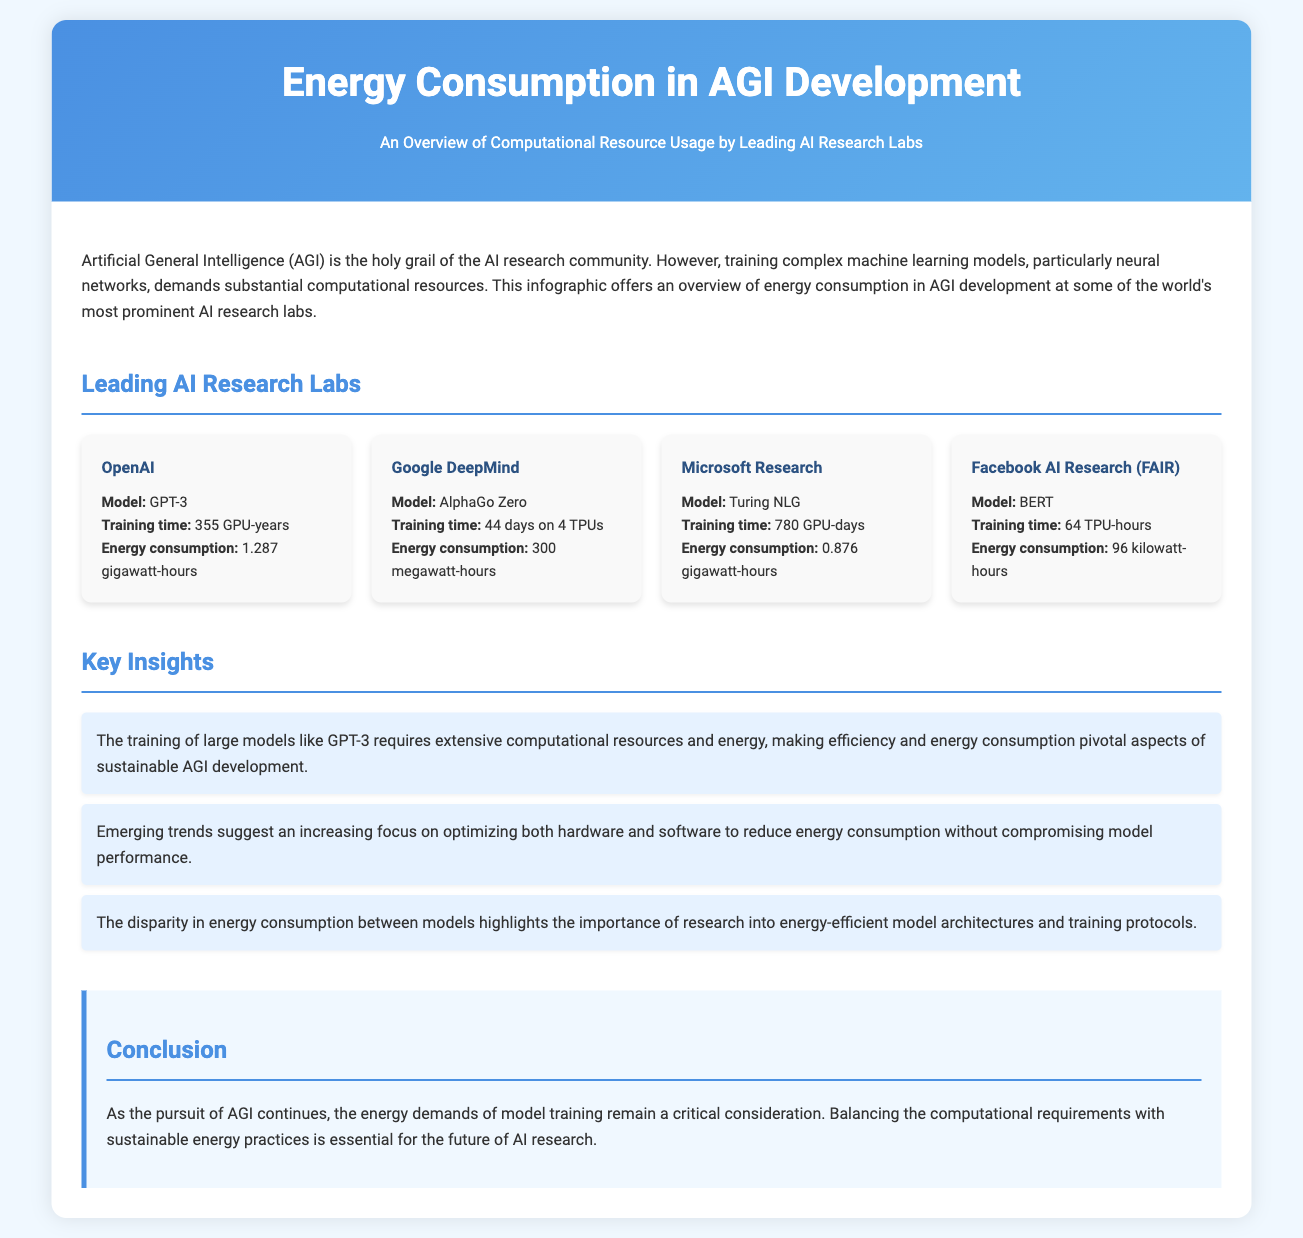What is the title of the infographic? The title of the infographic is presented at the top of the document and summarizes the main focus on energy consumption in AGI development.
Answer: Energy Consumption in AGI Development Which lab trained GPT-3? The document specifies that GPT-3 was trained by a prominent AI research lab outlined in the section on leading labs.
Answer: OpenAI How much energy did AlphaGo Zero consume? The document provides the energy consumption associated with training AlphaGo Zero, measured in megawatt-hours.
Answer: 300 megawatt-hours What is the training duration for Turing NLG? The infographic states the training time for Turing NLG in a specified unit, indicating how long the training process took.
Answer: 780 GPU-days What is a key insight mentioned in the infographic? This question identifies a significant takeaway presented in the insights section of the infographic, focusing on the relationship between energy consumption and model training.
Answer: The training of large models like GPT-3 requires extensive computational resources and energy Which model had the lowest energy consumption? The document compares the energy consumption of different models and indicates which had the least.
Answer: BERT What is the color of the header background? The colors used in the formatting of the infographic include specific tones mentioned in the CSS section, particularly for the header.
Answer: Linear-gradient of #4a90e2 and #63b3ed What is one of the major concerns regarding AGI development? The document emphasizes considerations related to energy consumption and sustainability, highlighting critical aspects for the future of research.
Answer: Energy demands of model training 